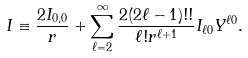Convert formula to latex. <formula><loc_0><loc_0><loc_500><loc_500>I \equiv \frac { 2 I _ { 0 , 0 } } { r } + \sum ^ { \infty } _ { \ell = 2 } \frac { 2 ( 2 \ell - 1 ) ! ! } { \ell ! r ^ { \ell + 1 } } I _ { \ell 0 } Y ^ { \ell 0 } .</formula> 